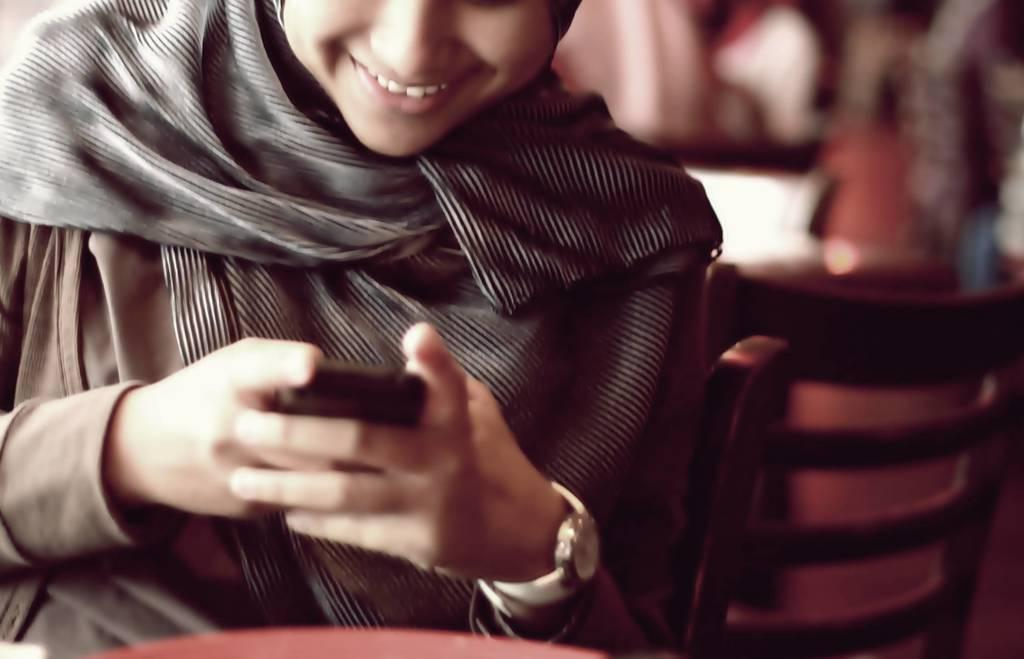Who or what is the main subject in the image? There is a person in the image. What can be observed about the person's attire? The person is wearing clothes. What object is the person holding in the image? The person is holding a phone. Can you describe the background of the image? The background of the image is blurred. What type of form can be seen in the image? There is no form present in the image; it features a person holding a phone with a blurred background. Is there a trail visible in the image? There is no trail visible in the image. 